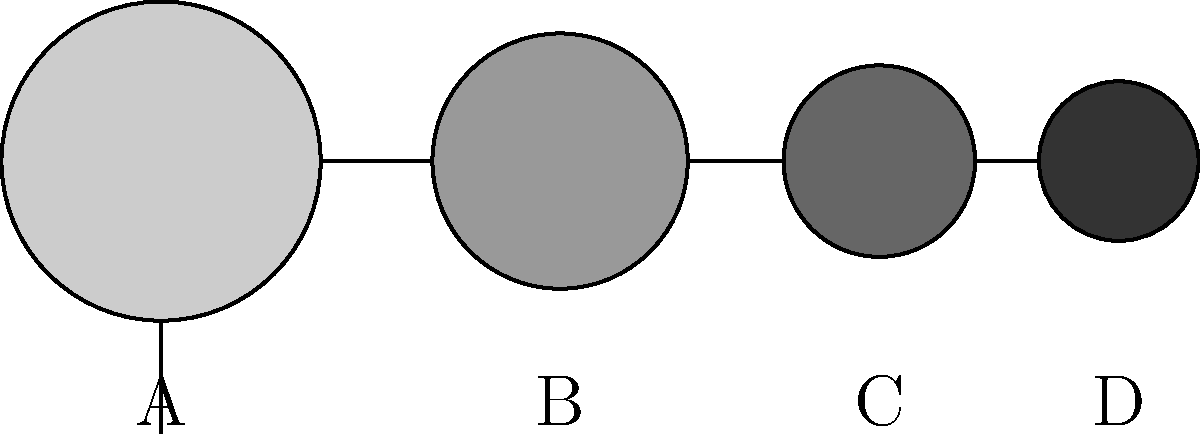Check out these awesome sports ball silhouettes! Which one do you think represents a basketball? This knowledge could totally impress your friends during the next game night! Let's break this down step-by-step to identify the basketball:

1. First, we need to consider the relative sizes of different sports balls:
   - Basketballs are generally larger than most other sports balls.
   - Footballs (soccer balls) are slightly smaller than basketballs.
   - Baseballs and tennis balls are much smaller.

2. Looking at the silhouettes:
   - Ball A is the largest, which matches the size of a basketball.
   - Ball B is slightly smaller, likely representing a football (soccer ball).
   - Balls C and D are much smaller, possibly representing a baseball and a tennis ball.

3. Shape considerations:
   - All silhouettes are perfectly round, which is accurate for most sports balls when viewed from this angle.
   - A basketball's circular shape is consistent from all angles.

4. Based on size and shape, we can conclude that Ball A most likely represents a basketball.

This analysis helps us confidently identify the basketball, which is crucial knowledge for impressing friends during sports discussions or game nights!
Answer: A 